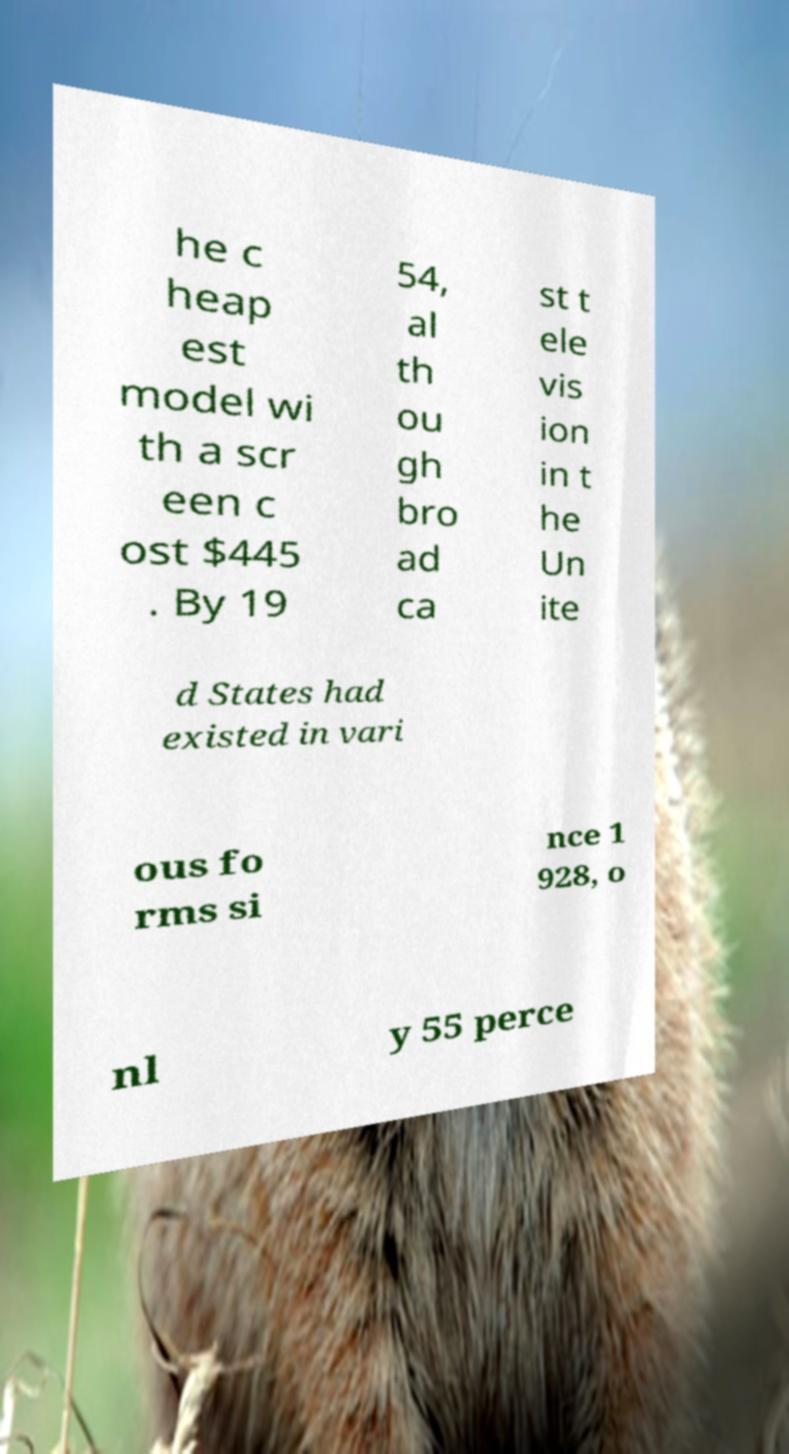For documentation purposes, I need the text within this image transcribed. Could you provide that? he c heap est model wi th a scr een c ost $445 . By 19 54, al th ou gh bro ad ca st t ele vis ion in t he Un ite d States had existed in vari ous fo rms si nce 1 928, o nl y 55 perce 